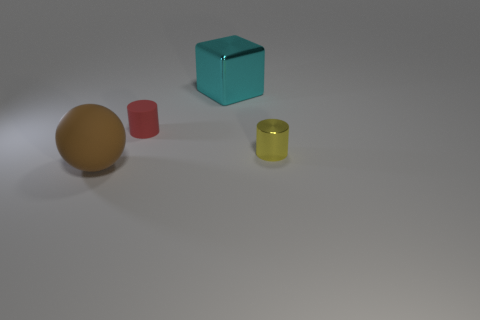What materials are the objects in the image likely made of? The objects in the image appear to be made from different materials. The big cyan block looks like it could be made of some type of plastic or acrylic. The yellow and red cylinders seem to be made of a matte material, possibly painted metal or plastic, and the golden sphere looks like it could be a polished metal or a plastic with a metallic finish. 